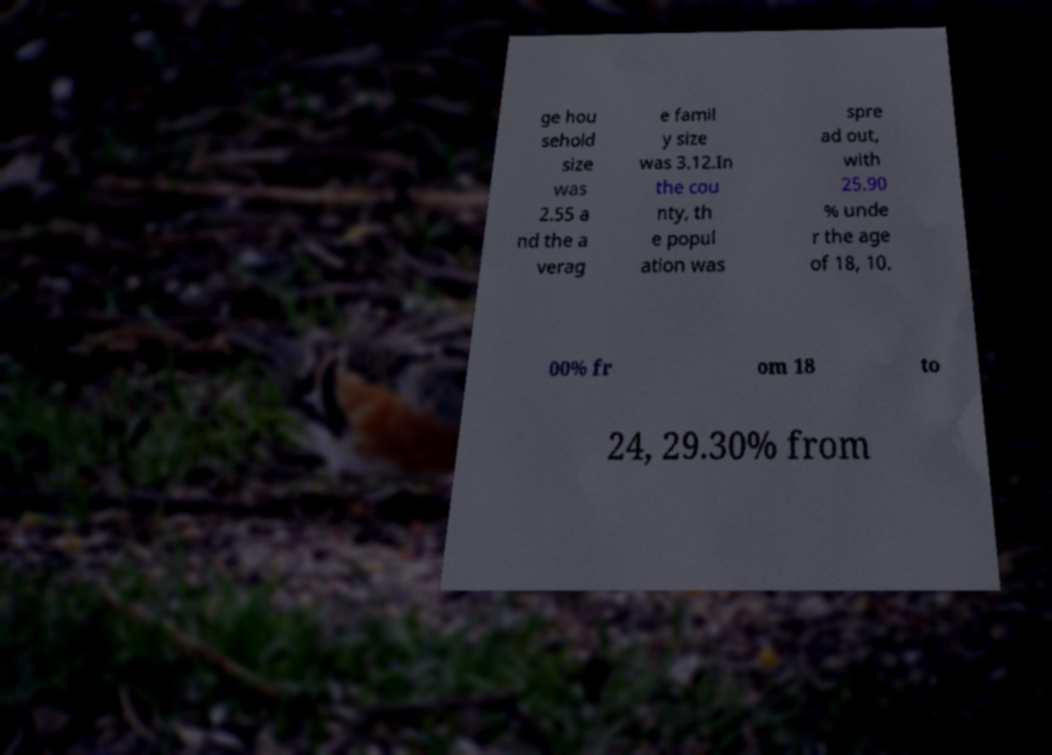There's text embedded in this image that I need extracted. Can you transcribe it verbatim? ge hou sehold size was 2.55 a nd the a verag e famil y size was 3.12.In the cou nty, th e popul ation was spre ad out, with 25.90 % unde r the age of 18, 10. 00% fr om 18 to 24, 29.30% from 